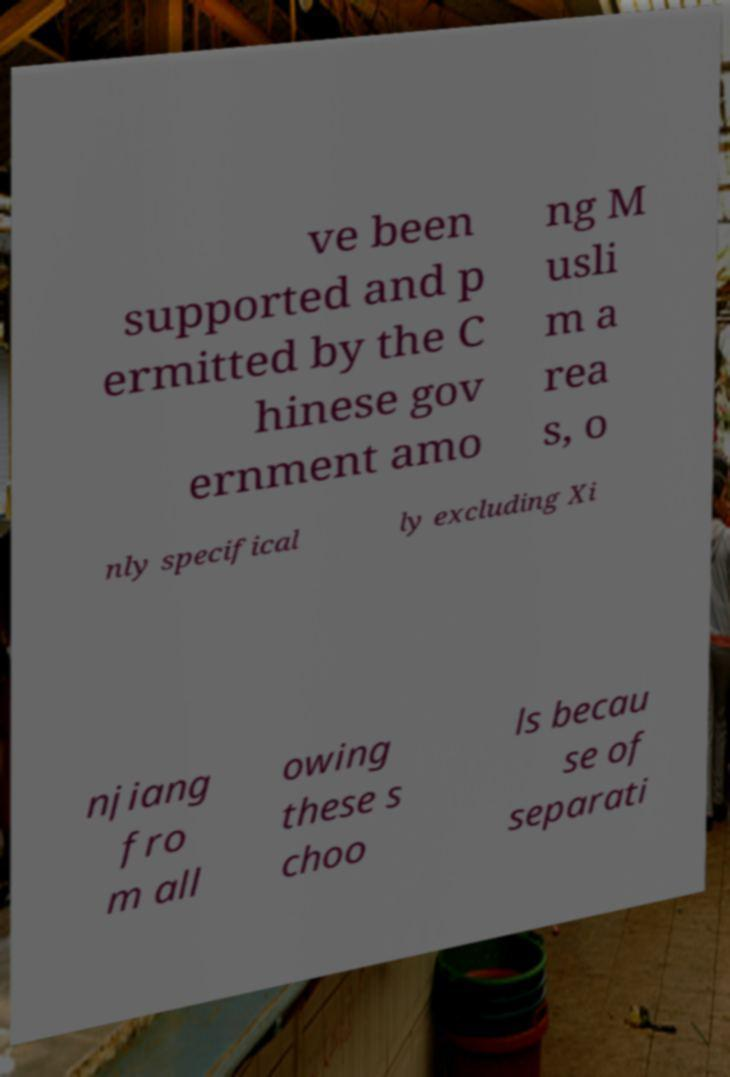I need the written content from this picture converted into text. Can you do that? ve been supported and p ermitted by the C hinese gov ernment amo ng M usli m a rea s, o nly specifical ly excluding Xi njiang fro m all owing these s choo ls becau se of separati 